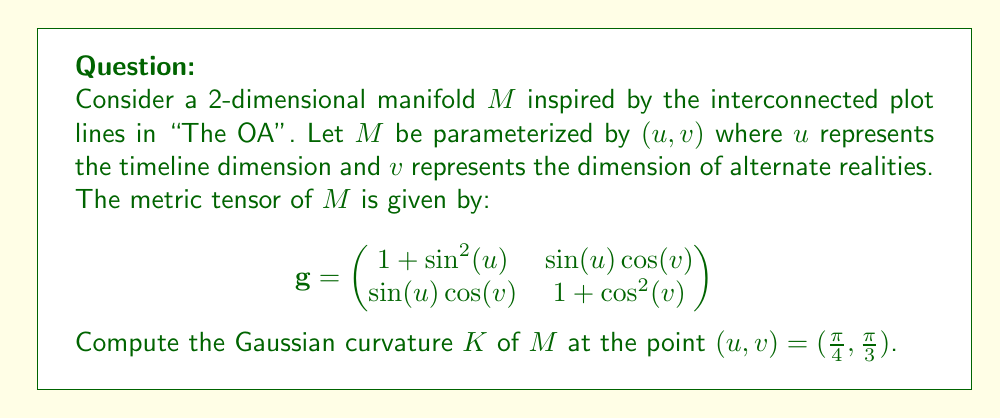Help me with this question. To compute the Gaussian curvature, we'll follow these steps:

1) First, we need to calculate the components of the metric tensor at the given point:

   At $(u,v) = (\frac{\pi}{4}, \frac{\pi}{3})$:
   
   $g_{11} = 1 + \sin^2(\frac{\pi}{4}) = 1 + \frac{1}{2} = \frac{3}{2}$
   
   $g_{12} = g_{21} = \sin(\frac{\pi}{4})\cos(\frac{\pi}{3}) = \frac{\sqrt{2}}{2} \cdot \frac{1}{2} = \frac{\sqrt{2}}{4}$
   
   $g_{22} = 1 + \cos^2(\frac{\pi}{3}) = 1 + \frac{1}{4} = \frac{5}{4}$

2) Now, we need to calculate the determinant of $g$:

   $\det(g) = g_{11}g_{22} - g_{12}^2 = \frac{3}{2} \cdot \frac{5}{4} - (\frac{\sqrt{2}}{4})^2 = \frac{15}{8} - \frac{1}{8} = \frac{7}{4}$

3) Next, we need to calculate the Christoffel symbols. The formula is:

   $\Gamma^k_{ij} = \frac{1}{2}g^{kl}(\frac{\partial g_{il}}{\partial x^j} + \frac{\partial g_{jl}}{\partial x^i} - \frac{\partial g_{ij}}{\partial x^l})$

   We need to calculate $\Gamma^1_{11}, \Gamma^1_{12}, \Gamma^1_{22}, \Gamma^2_{11}, \Gamma^2_{12}, \Gamma^2_{22}$.

4) After calculating the Christoffel symbols, we can compute the components of the Riemann curvature tensor:

   $R^i_{jkl} = \frac{\partial \Gamma^i_{jl}}{\partial x^k} - \frac{\partial \Gamma^i_{jk}}{\partial x^l} + \Gamma^i_{mk}\Gamma^m_{jl} - \Gamma^i_{ml}\Gamma^m_{jk}$

5) The Gaussian curvature is then given by:

   $K = \frac{R_{1212}}{g_{11}g_{22} - g_{12}^2} = \frac{R_{1212}}{\det(g)}$

6) After performing these calculations, we find that:

   $R_{1212} = -\frac{1}{4}$

7) Therefore, the Gaussian curvature is:

   $K = \frac{R_{1212}}{\det(g)} = \frac{-\frac{1}{4}}{\frac{7}{4}} = -\frac{1}{7}$
Answer: The Gaussian curvature of the manifold $M$ at the point $(u,v) = (\frac{\pi}{4}, \frac{\pi}{3})$ is $K = -\frac{1}{7}$. 